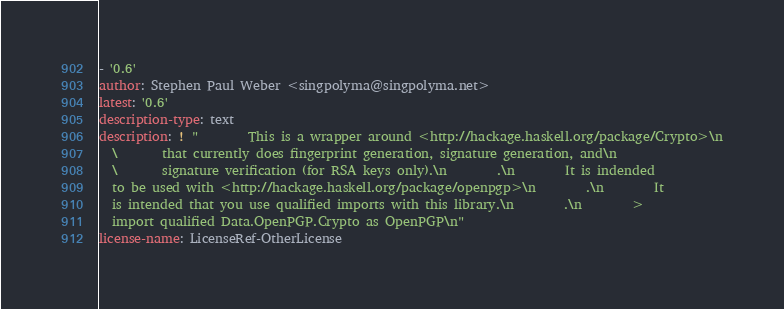Convert code to text. <code><loc_0><loc_0><loc_500><loc_500><_YAML_>- '0.6'
author: Stephen Paul Weber <singpolyma@singpolyma.net>
latest: '0.6'
description-type: text
description: ! "        This is a wrapper around <http://hackage.haskell.org/package/Crypto>\n
  \       that currently does fingerprint generation, signature generation, and\n
  \       signature verification (for RSA keys only).\n        .\n        It is indended
  to be used with <http://hackage.haskell.org/package/openpgp>\n        .\n        It
  is intended that you use qualified imports with this library.\n        .\n        >
  import qualified Data.OpenPGP.Crypto as OpenPGP\n"
license-name: LicenseRef-OtherLicense
</code> 